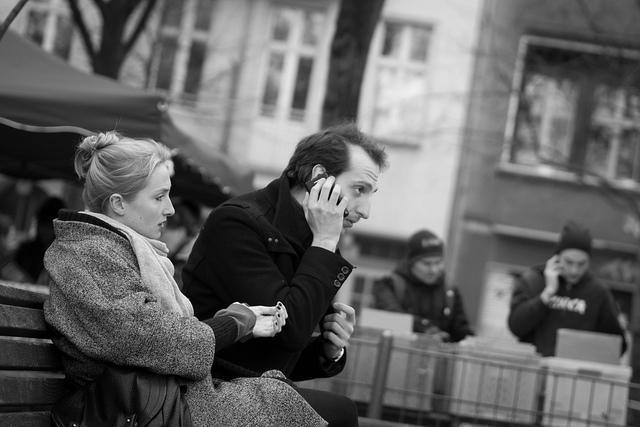How many people are wearing glasses?
Give a very brief answer. 0. How many people can be seen?
Give a very brief answer. 4. How many benches are in the photo?
Give a very brief answer. 1. 